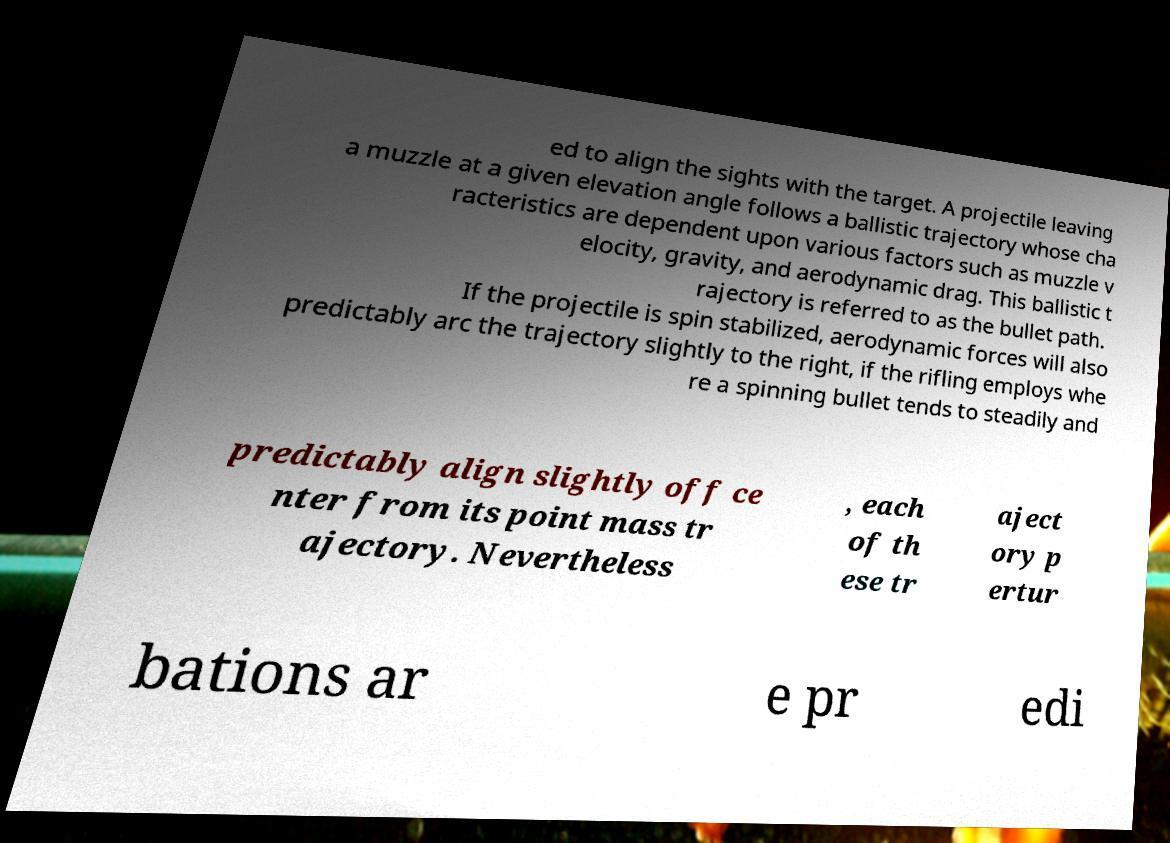There's text embedded in this image that I need extracted. Can you transcribe it verbatim? ed to align the sights with the target. A projectile leaving a muzzle at a given elevation angle follows a ballistic trajectory whose cha racteristics are dependent upon various factors such as muzzle v elocity, gravity, and aerodynamic drag. This ballistic t rajectory is referred to as the bullet path. If the projectile is spin stabilized, aerodynamic forces will also predictably arc the trajectory slightly to the right, if the rifling employs whe re a spinning bullet tends to steadily and predictably align slightly off ce nter from its point mass tr ajectory. Nevertheless , each of th ese tr aject ory p ertur bations ar e pr edi 